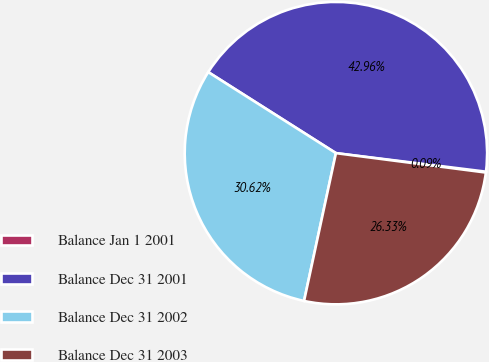Convert chart to OTSL. <chart><loc_0><loc_0><loc_500><loc_500><pie_chart><fcel>Balance Jan 1 2001<fcel>Balance Dec 31 2001<fcel>Balance Dec 31 2002<fcel>Balance Dec 31 2003<nl><fcel>0.09%<fcel>42.96%<fcel>30.62%<fcel>26.33%<nl></chart> 